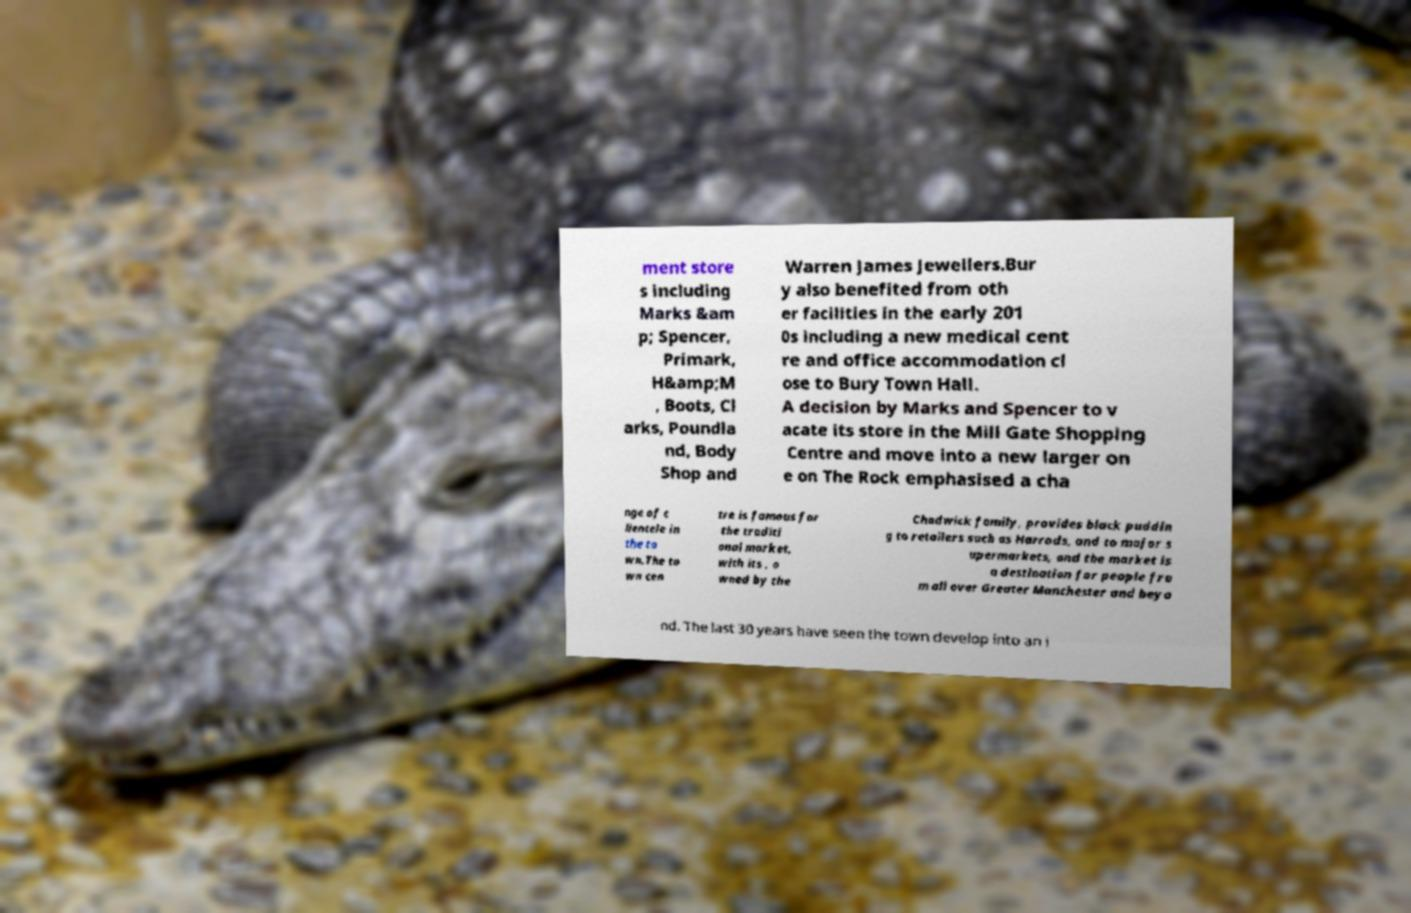Can you read and provide the text displayed in the image?This photo seems to have some interesting text. Can you extract and type it out for me? ment store s including Marks &am p; Spencer, Primark, H&amp;M , Boots, Cl arks, Poundla nd, Body Shop and Warren James Jewellers.Bur y also benefited from oth er facilities in the early 201 0s including a new medical cent re and office accommodation cl ose to Bury Town Hall. A decision by Marks and Spencer to v acate its store in the Mill Gate Shopping Centre and move into a new larger on e on The Rock emphasised a cha nge of c lientele in the to wn.The to wn cen tre is famous for the traditi onal market, with its , o wned by the Chadwick family, provides black puddin g to retailers such as Harrods, and to major s upermarkets, and the market is a destination for people fro m all over Greater Manchester and beyo nd. The last 30 years have seen the town develop into an i 